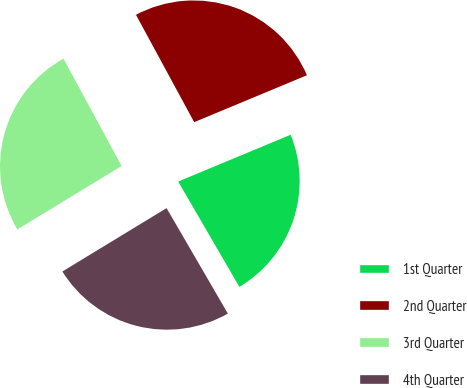<chart> <loc_0><loc_0><loc_500><loc_500><pie_chart><fcel>1st Quarter<fcel>2nd Quarter<fcel>3rd Quarter<fcel>4th Quarter<nl><fcel>22.9%<fcel>26.63%<fcel>25.79%<fcel>24.68%<nl></chart> 